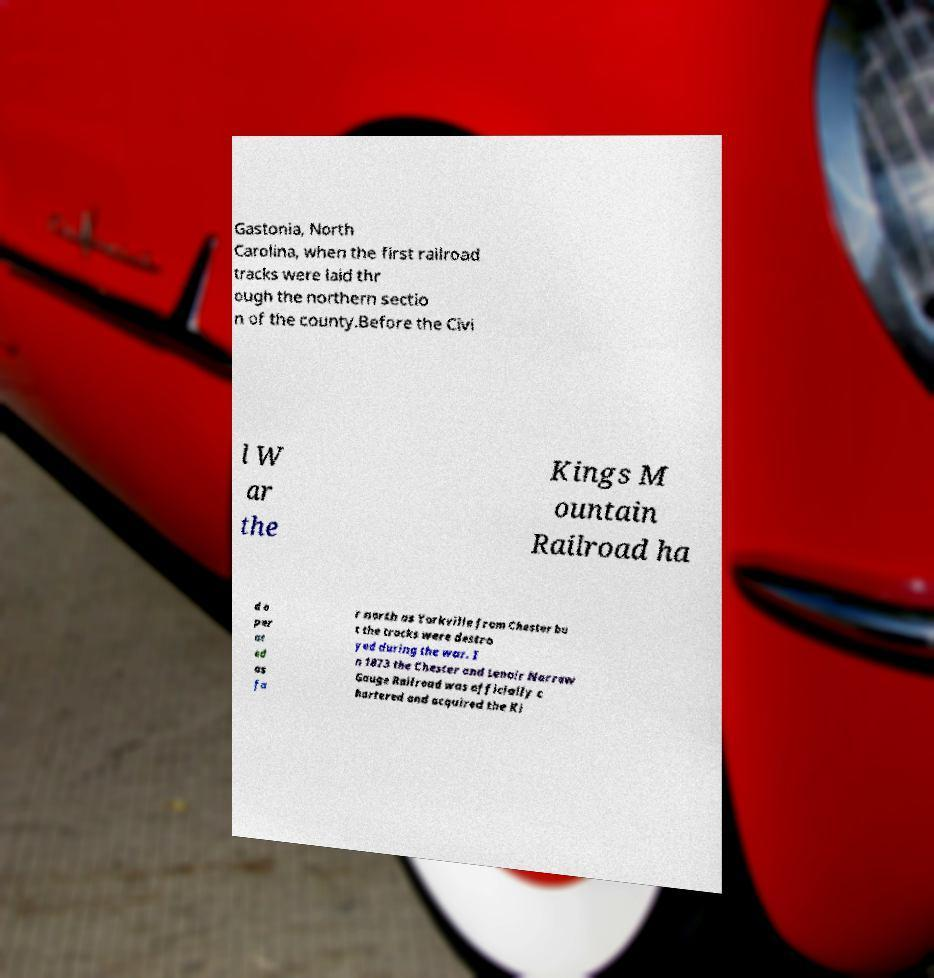Please read and relay the text visible in this image. What does it say? Gastonia, North Carolina, when the first railroad tracks were laid thr ough the northern sectio n of the county.Before the Civi l W ar the Kings M ountain Railroad ha d o per at ed as fa r north as Yorkville from Chester bu t the tracks were destro yed during the war. I n 1873 the Chester and Lenoir Narrow Gauge Railroad was officially c hartered and acquired the Ki 